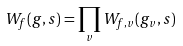<formula> <loc_0><loc_0><loc_500><loc_500>W _ { f } ( g , s ) = \prod _ { v } W _ { f , v } ( g _ { v } , s )</formula> 